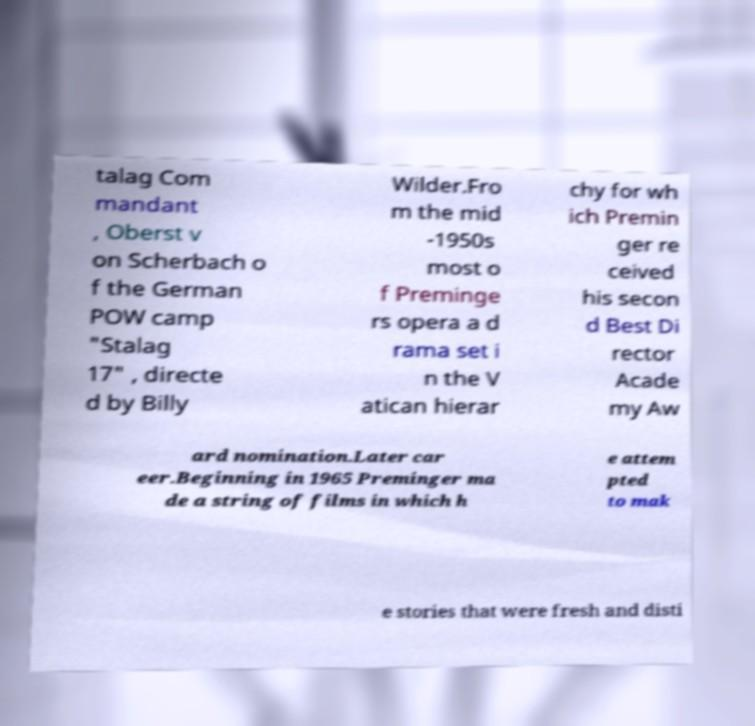Could you extract and type out the text from this image? talag Com mandant , Oberst v on Scherbach o f the German POW camp "Stalag 17" , directe d by Billy Wilder.Fro m the mid -1950s most o f Preminge rs opera a d rama set i n the V atican hierar chy for wh ich Premin ger re ceived his secon d Best Di rector Acade my Aw ard nomination.Later car eer.Beginning in 1965 Preminger ma de a string of films in which h e attem pted to mak e stories that were fresh and disti 